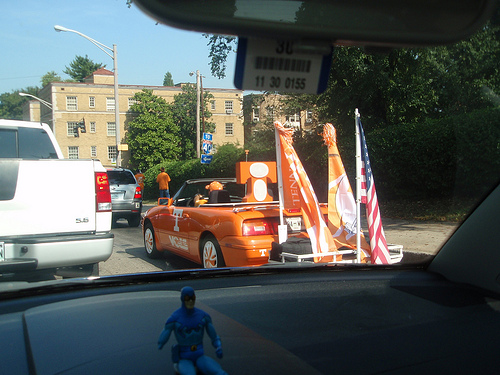<image>
Is the street light on the building? No. The street light is not positioned on the building. They may be near each other, but the street light is not supported by or resting on top of the building. Where is the convertible in relation to the superhero? Is it behind the superhero? Yes. From this viewpoint, the convertible is positioned behind the superhero, with the superhero partially or fully occluding the convertible. Is there a flag in front of the car? No. The flag is not in front of the car. The spatial positioning shows a different relationship between these objects. 